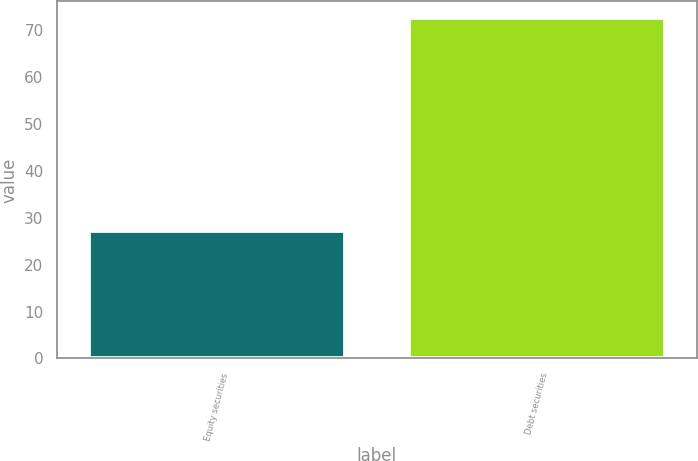Convert chart to OTSL. <chart><loc_0><loc_0><loc_500><loc_500><bar_chart><fcel>Equity securities<fcel>Debt securities<nl><fcel>27.1<fcel>72.5<nl></chart> 